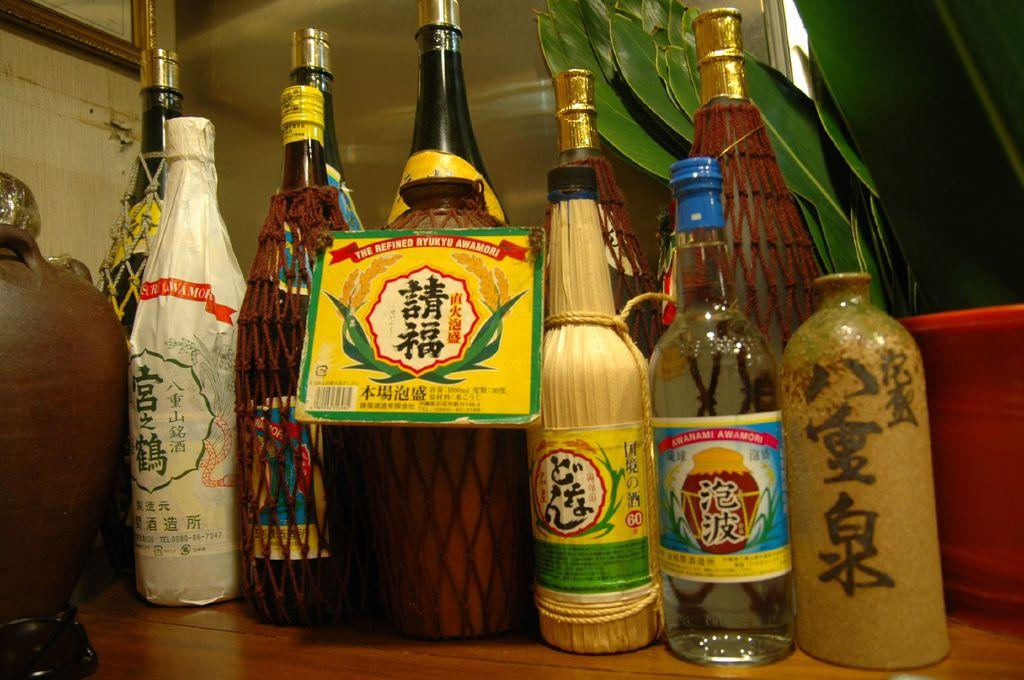<image>
Create a compact narrative representing the image presented. many bottles of liquor including Refined Ryukyu line a table 